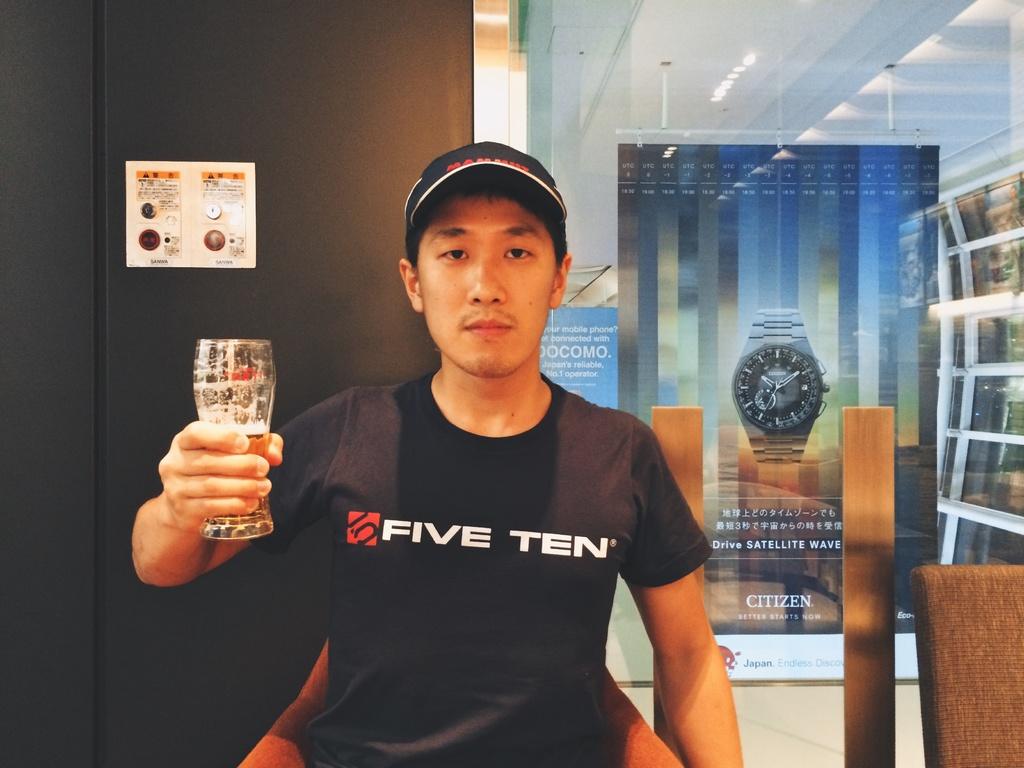What numbers are mentioned on the man's black shirt?
Your answer should be compact. Five ten. What text is in the background ad?
Keep it short and to the point. Citizen. 